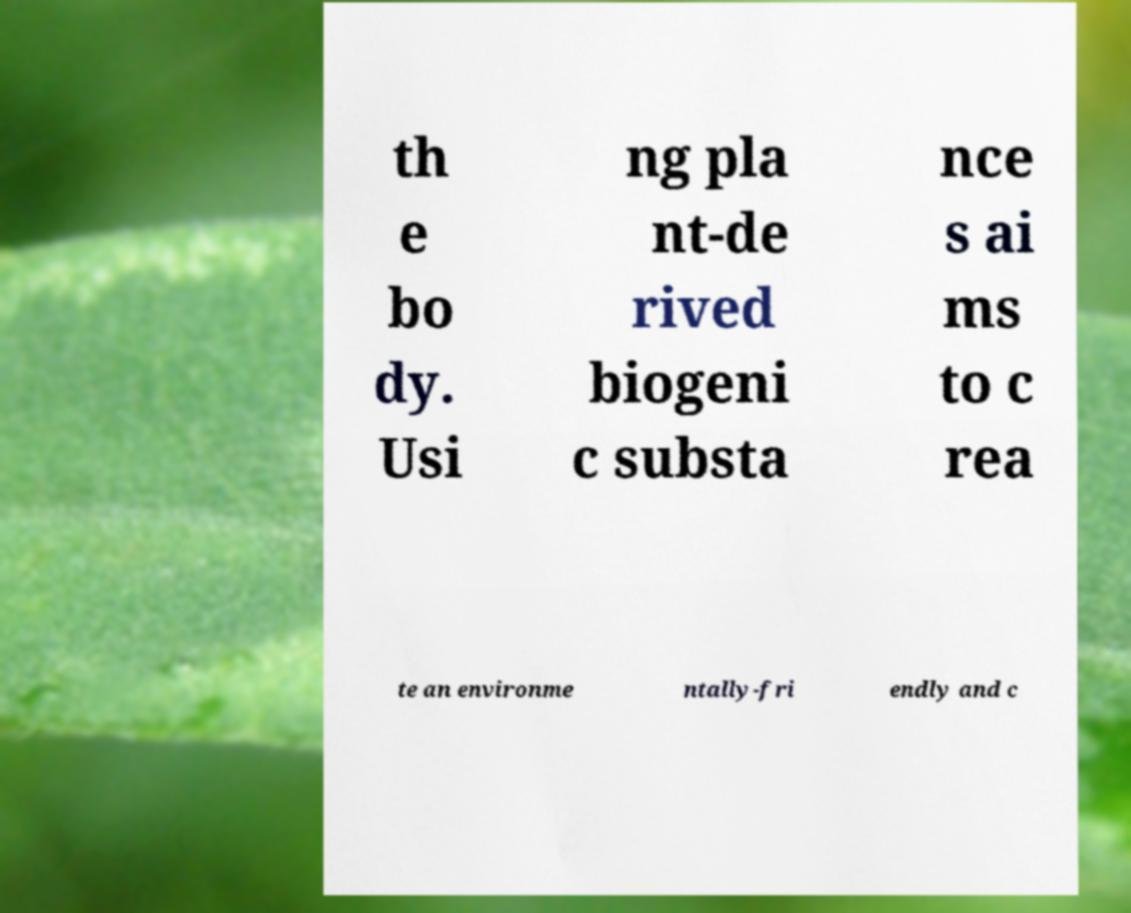Please read and relay the text visible in this image. What does it say? th e bo dy. Usi ng pla nt-de rived biogeni c substa nce s ai ms to c rea te an environme ntally-fri endly and c 